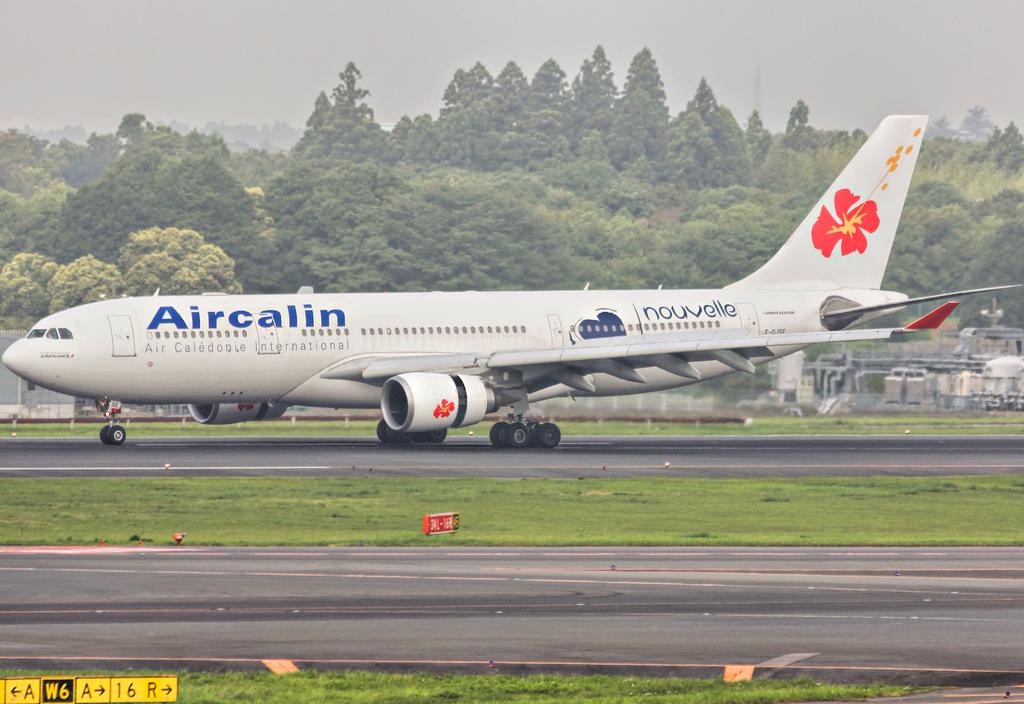What airline in this?
Provide a short and direct response. Aircalin. What are the letters on the yellow sign on the bottom left?
Offer a terse response. A w6 a 16 r. 